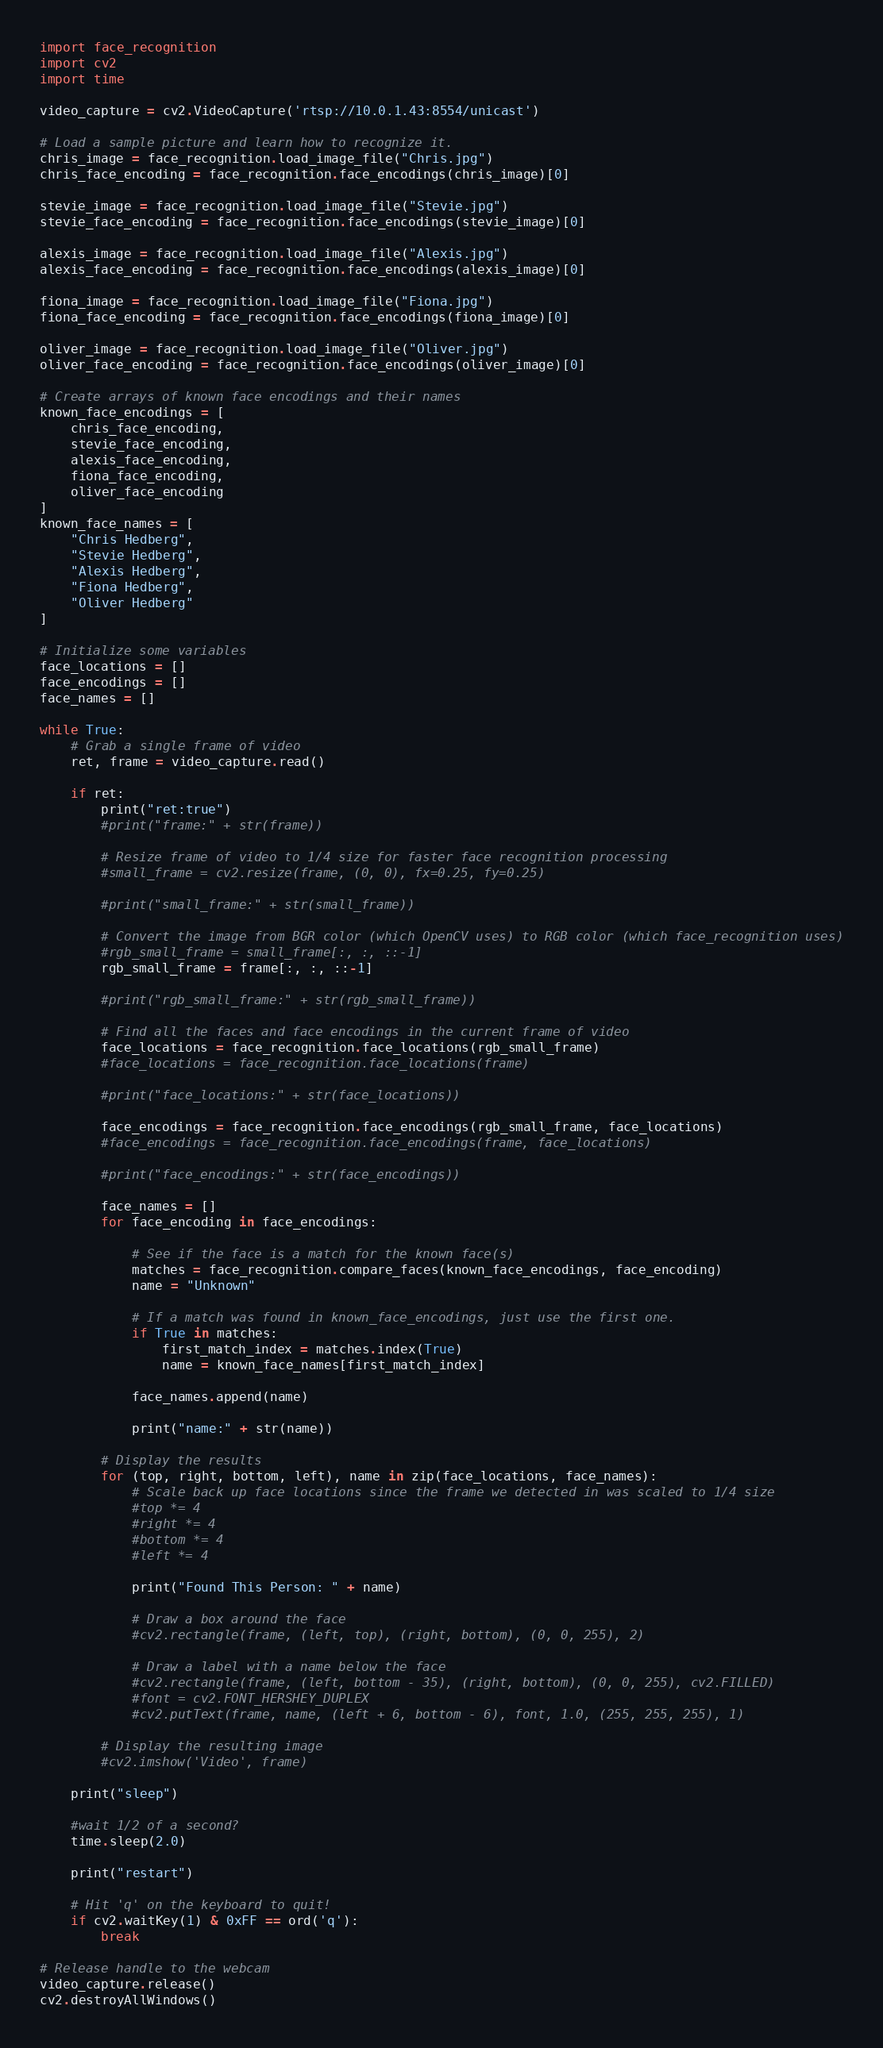Convert code to text. <code><loc_0><loc_0><loc_500><loc_500><_Python_>import face_recognition
import cv2
import time

video_capture = cv2.VideoCapture('rtsp://10.0.1.43:8554/unicast')

# Load a sample picture and learn how to recognize it.
chris_image = face_recognition.load_image_file("Chris.jpg")
chris_face_encoding = face_recognition.face_encodings(chris_image)[0]

stevie_image = face_recognition.load_image_file("Stevie.jpg")
stevie_face_encoding = face_recognition.face_encodings(stevie_image)[0]

alexis_image = face_recognition.load_image_file("Alexis.jpg")
alexis_face_encoding = face_recognition.face_encodings(alexis_image)[0]

fiona_image = face_recognition.load_image_file("Fiona.jpg")
fiona_face_encoding = face_recognition.face_encodings(fiona_image)[0]

oliver_image = face_recognition.load_image_file("Oliver.jpg")
oliver_face_encoding = face_recognition.face_encodings(oliver_image)[0]

# Create arrays of known face encodings and their names
known_face_encodings = [
    chris_face_encoding,
    stevie_face_encoding,
    alexis_face_encoding,
    fiona_face_encoding,
    oliver_face_encoding
]
known_face_names = [
    "Chris Hedberg",
    "Stevie Hedberg",
    "Alexis Hedberg",
    "Fiona Hedberg",
    "Oliver Hedberg"
]

# Initialize some variables
face_locations = []
face_encodings = []
face_names = []

while True:
    # Grab a single frame of video
    ret, frame = video_capture.read()

    if ret:
        print("ret:true")
        #print("frame:" + str(frame))

        # Resize frame of video to 1/4 size for faster face recognition processing
        #small_frame = cv2.resize(frame, (0, 0), fx=0.25, fy=0.25)

        #print("small_frame:" + str(small_frame))

        # Convert the image from BGR color (which OpenCV uses) to RGB color (which face_recognition uses)
        #rgb_small_frame = small_frame[:, :, ::-1]
        rgb_small_frame = frame[:, :, ::-1]

        #print("rgb_small_frame:" + str(rgb_small_frame))

        # Find all the faces and face encodings in the current frame of video
        face_locations = face_recognition.face_locations(rgb_small_frame)
        #face_locations = face_recognition.face_locations(frame)

        #print("face_locations:" + str(face_locations))

        face_encodings = face_recognition.face_encodings(rgb_small_frame, face_locations)
        #face_encodings = face_recognition.face_encodings(frame, face_locations)

        #print("face_encodings:" + str(face_encodings))

        face_names = []
        for face_encoding in face_encodings:

            # See if the face is a match for the known face(s)
            matches = face_recognition.compare_faces(known_face_encodings, face_encoding)
            name = "Unknown"

            # If a match was found in known_face_encodings, just use the first one.
            if True in matches:
                first_match_index = matches.index(True)
                name = known_face_names[first_match_index]

            face_names.append(name)

            print("name:" + str(name))

        # Display the results
        for (top, right, bottom, left), name in zip(face_locations, face_names):
            # Scale back up face locations since the frame we detected in was scaled to 1/4 size
            #top *= 4
            #right *= 4
            #bottom *= 4
            #left *= 4

            print("Found This Person: " + name)

            # Draw a box around the face
            #cv2.rectangle(frame, (left, top), (right, bottom), (0, 0, 255), 2)

            # Draw a label with a name below the face
            #cv2.rectangle(frame, (left, bottom - 35), (right, bottom), (0, 0, 255), cv2.FILLED)
            #font = cv2.FONT_HERSHEY_DUPLEX
            #cv2.putText(frame, name, (left + 6, bottom - 6), font, 1.0, (255, 255, 255), 1)

        # Display the resulting image
        #cv2.imshow('Video', frame)

    print("sleep")

    #wait 1/2 of a second?
    time.sleep(2.0)

    print("restart")

    # Hit 'q' on the keyboard to quit!
    if cv2.waitKey(1) & 0xFF == ord('q'):
        break

# Release handle to the webcam
video_capture.release()
cv2.destroyAllWindows()
</code> 